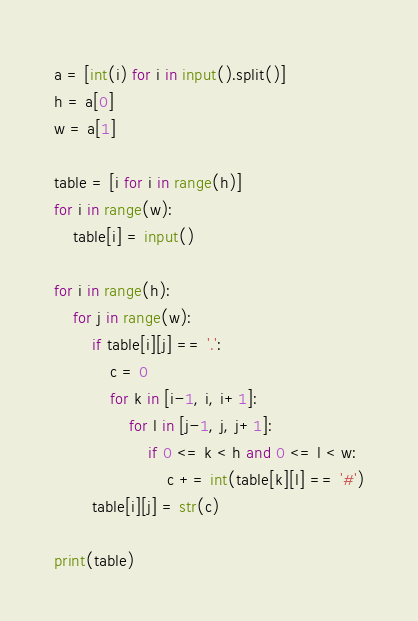<code> <loc_0><loc_0><loc_500><loc_500><_Python_>a = [int(i) for i in input().split()]
h = a[0]
w = a[1]

table = [i for i in range(h)]
for i in range(w):
    table[i] = input()

for i in range(h):
    for j in range(w):
        if table[i][j] == '.':
            c = 0
            for k in [i-1, i, i+1]:
                for l in [j-1, j, j+1]:
                    if 0 <= k < h and 0 <= l < w:
                        c += int(table[k][l] == '#')
        table[i][j] = str(c)

print(table)</code> 